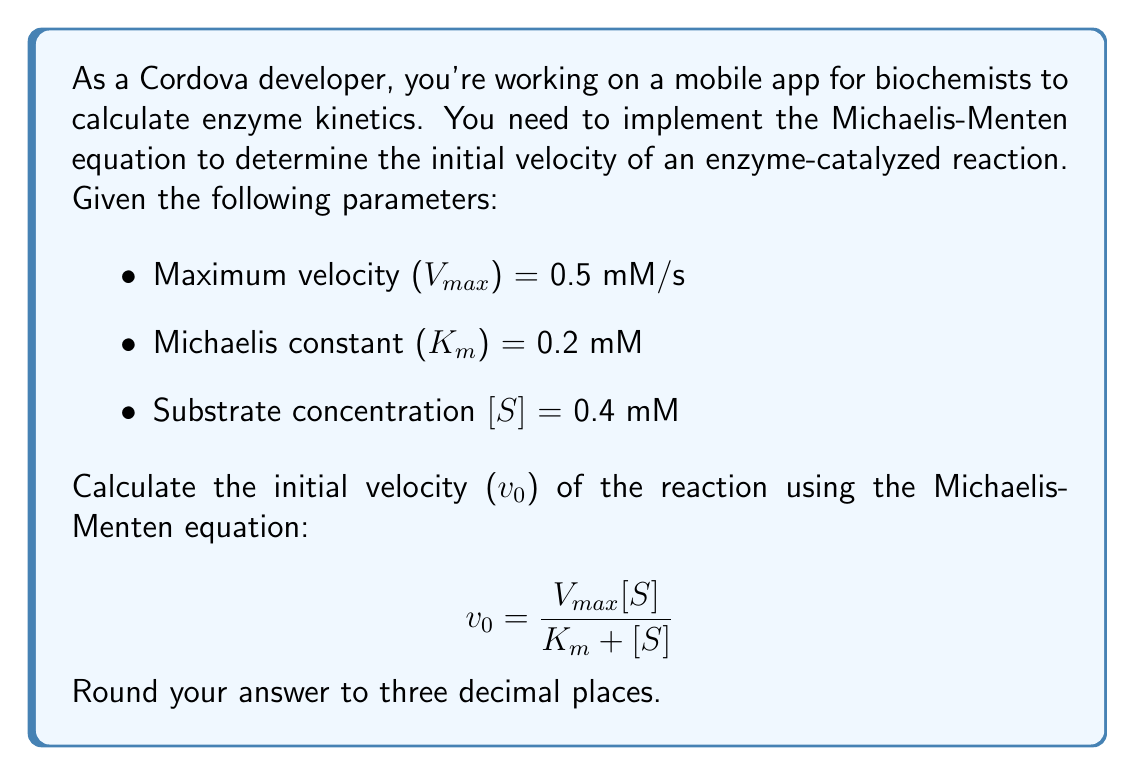Give your solution to this math problem. To solve this problem, we'll use the Michaelis-Menten equation and plug in the given values:

1. Recall the Michaelis-Menten equation:
   $$ v_0 = \frac{V_{max}[S]}{K_m + [S]} $$

2. Substitute the given values:
   - V_max = 0.5 mM/s
   - K_m = 0.2 mM
   - [S] = 0.4 mM

3. Plug these values into the equation:
   $$ v_0 = \frac{0.5 \cdot 0.4}{0.2 + 0.4} $$

4. Simplify the numerator:
   $$ v_0 = \frac{0.2}{0.2 + 0.4} $$

5. Add the denominator:
   $$ v_0 = \frac{0.2}{0.6} $$

6. Divide:
   $$ v_0 = 0.3333... $$

7. Round to three decimal places:
   $$ v_0 \approx 0.333 \text{ mM/s} $$

Therefore, the initial velocity of the enzyme-catalyzed reaction is approximately 0.333 mM/s.
Answer: 0.333 mM/s 